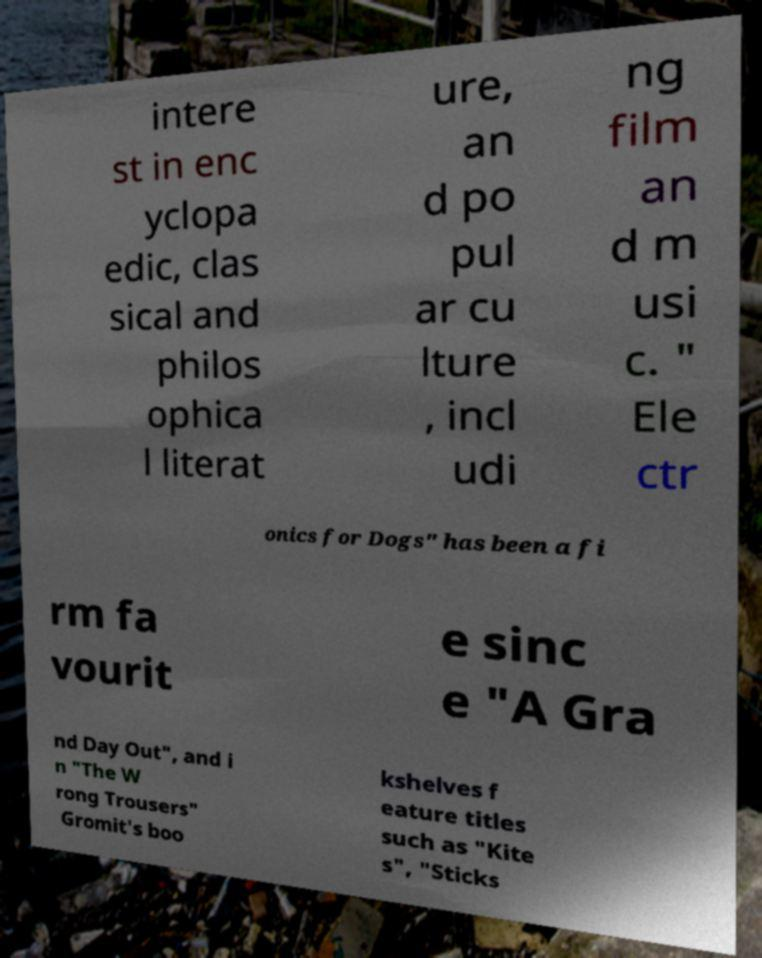For documentation purposes, I need the text within this image transcribed. Could you provide that? intere st in enc yclopa edic, clas sical and philos ophica l literat ure, an d po pul ar cu lture , incl udi ng film an d m usi c. " Ele ctr onics for Dogs" has been a fi rm fa vourit e sinc e "A Gra nd Day Out", and i n "The W rong Trousers" Gromit's boo kshelves f eature titles such as "Kite s", "Sticks 